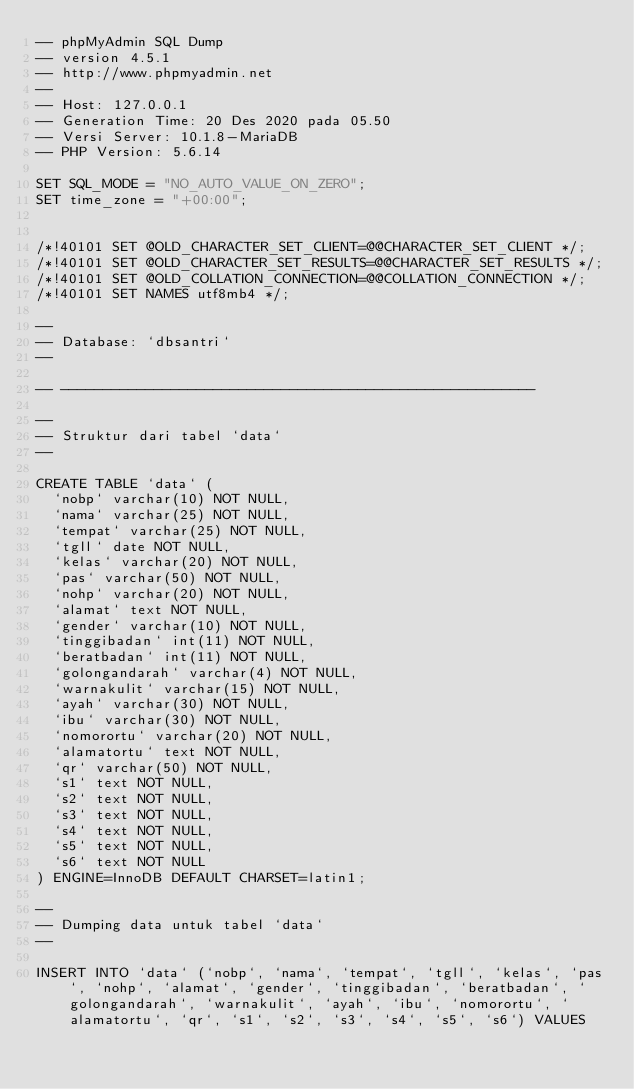Convert code to text. <code><loc_0><loc_0><loc_500><loc_500><_SQL_>-- phpMyAdmin SQL Dump
-- version 4.5.1
-- http://www.phpmyadmin.net
--
-- Host: 127.0.0.1
-- Generation Time: 20 Des 2020 pada 05.50
-- Versi Server: 10.1.8-MariaDB
-- PHP Version: 5.6.14

SET SQL_MODE = "NO_AUTO_VALUE_ON_ZERO";
SET time_zone = "+00:00";


/*!40101 SET @OLD_CHARACTER_SET_CLIENT=@@CHARACTER_SET_CLIENT */;
/*!40101 SET @OLD_CHARACTER_SET_RESULTS=@@CHARACTER_SET_RESULTS */;
/*!40101 SET @OLD_COLLATION_CONNECTION=@@COLLATION_CONNECTION */;
/*!40101 SET NAMES utf8mb4 */;

--
-- Database: `dbsantri`
--

-- --------------------------------------------------------

--
-- Struktur dari tabel `data`
--

CREATE TABLE `data` (
  `nobp` varchar(10) NOT NULL,
  `nama` varchar(25) NOT NULL,
  `tempat` varchar(25) NOT NULL,
  `tgll` date NOT NULL,
  `kelas` varchar(20) NOT NULL,
  `pas` varchar(50) NOT NULL,
  `nohp` varchar(20) NOT NULL,
  `alamat` text NOT NULL,
  `gender` varchar(10) NOT NULL,
  `tinggibadan` int(11) NOT NULL,
  `beratbadan` int(11) NOT NULL,
  `golongandarah` varchar(4) NOT NULL,
  `warnakulit` varchar(15) NOT NULL,
  `ayah` varchar(30) NOT NULL,
  `ibu` varchar(30) NOT NULL,
  `nomorortu` varchar(20) NOT NULL,
  `alamatortu` text NOT NULL,
  `qr` varchar(50) NOT NULL,
  `s1` text NOT NULL,
  `s2` text NOT NULL,
  `s3` text NOT NULL,
  `s4` text NOT NULL,
  `s5` text NOT NULL,
  `s6` text NOT NULL
) ENGINE=InnoDB DEFAULT CHARSET=latin1;

--
-- Dumping data untuk tabel `data`
--

INSERT INTO `data` (`nobp`, `nama`, `tempat`, `tgll`, `kelas`, `pas`, `nohp`, `alamat`, `gender`, `tinggibadan`, `beratbadan`, `golongandarah`, `warnakulit`, `ayah`, `ibu`, `nomorortu`, `alamatortu`, `qr`, `s1`, `s2`, `s3`, `s4`, `s5`, `s6`) VALUES</code> 